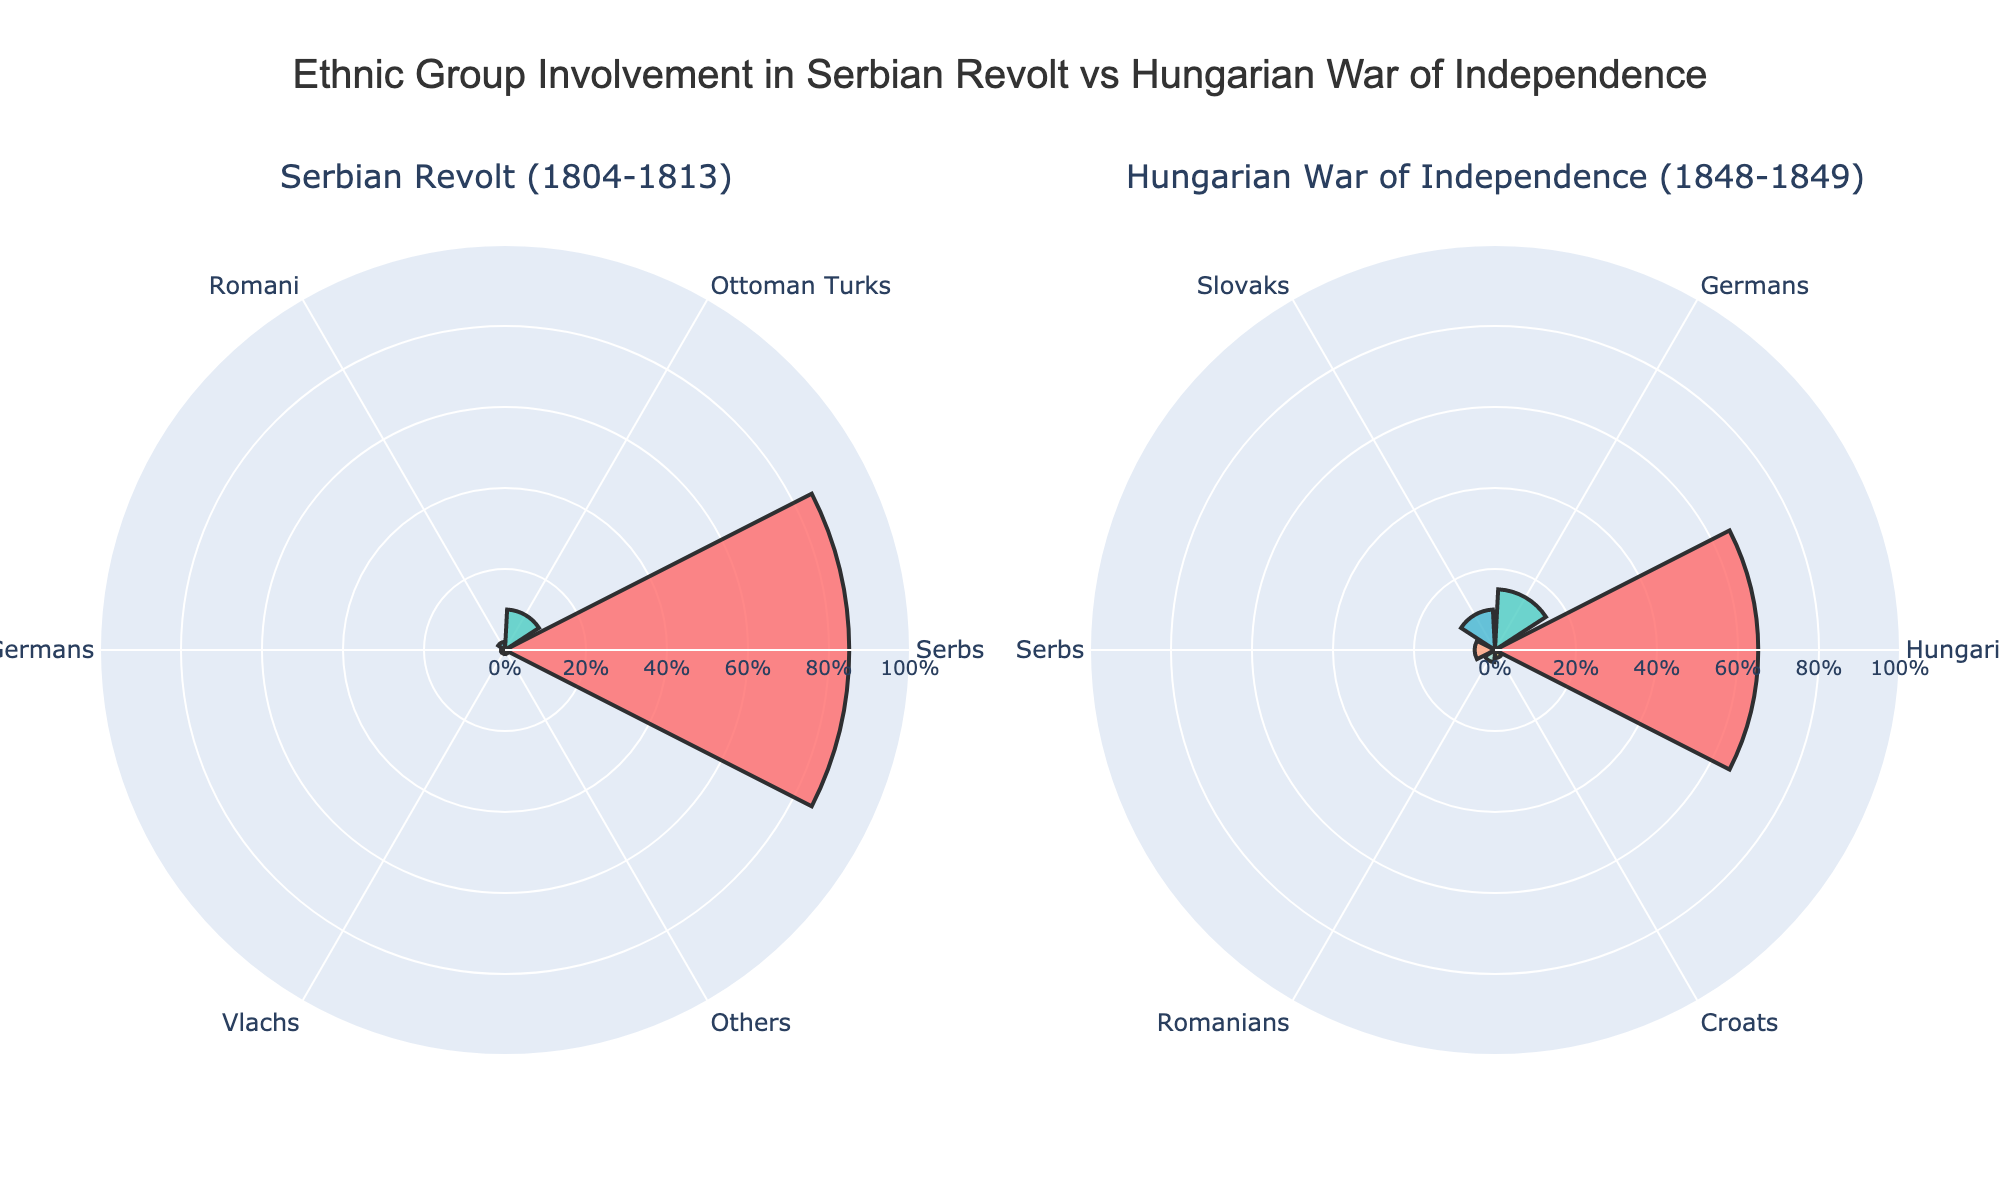what is the title of the plot? The title is located at the top center of the plot and provides a brief description of the data being visualized. It reads "Ethnic Group Involvement in Serbian Revolt vs Hungarian War of Independence."
Answer: Ethnic Group Involvement in Serbian Revolt vs Hungarian War of Independence How many ethnic groups were involved in the Serbian Revolt (1804-1813)? The count can be obtained by looking at the unique ethnic groups listed for the Serbian Revolt subplot on the left side of the figure. There are markers for Serbs, Ottoman Turks, Romani, Austrian Germans, Vlachs, and Others.
Answer: 6 Which ethnic group had the highest representation in the Hungarian War of Independence (1848-1849)? By checking the rose chart segment with the largest radial distance in the Hungarian War subplot on the right, you will see that Hungarians had the highest percentage.
Answer: Hungarians What percentage of the Ottoman Turks were involved in the Serbian Revolt (1804-1813)? Look at the legend and the corresponding value for Ottoman Turks in the rose chart for the Serbian Revolt. The radial distance value represents the percentage, which is 10%.
Answer: 10% Compare the representation of Serbs in both events. Which event had a higher percentage of Serbs involved? By comparing the radial distances for Serbs in both subplots, the plot shows that 85% of Serbs were involved in the Serbian Revolt, whereas only 5% were involved in the Hungarian War.
Answer: Serbian Revolt What is the total percentage of ethnic groups marked as 'Others' in the Serbian Revolt (1804-1813)? According to the segment labeled 'Others' in the Serbian Revolt subplot, the radial distance represents 1% of the total involvement in that event.
Answer: 1% What is the difference in percentages between the ethnic group with the highest and the lowest representation in the Hungarian War of Independence (1848-1849)? The highest percentage is for Hungarians at 65%, and the lowest is for Croats at 2%. The difference is calculated by subtracting 2 from 65.
Answer: 63% How do the involvement percentages of Romani compare between the two events? By comparing the segments labeled Romani in both subplots, the plot shows 2% in the Serbian Revolt and no explicit representation in the Hungarian War. This means Romani were significantly more represented in the Serbian Revolt.
Answer: Higher in Serbian Revolt 